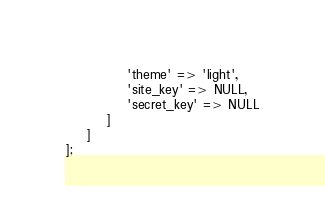<code> <loc_0><loc_0><loc_500><loc_500><_PHP_>            'theme' => 'light',
            'site_key' => NULL,
            'secret_key' => NULL
        ]
    ]
];
</code> 